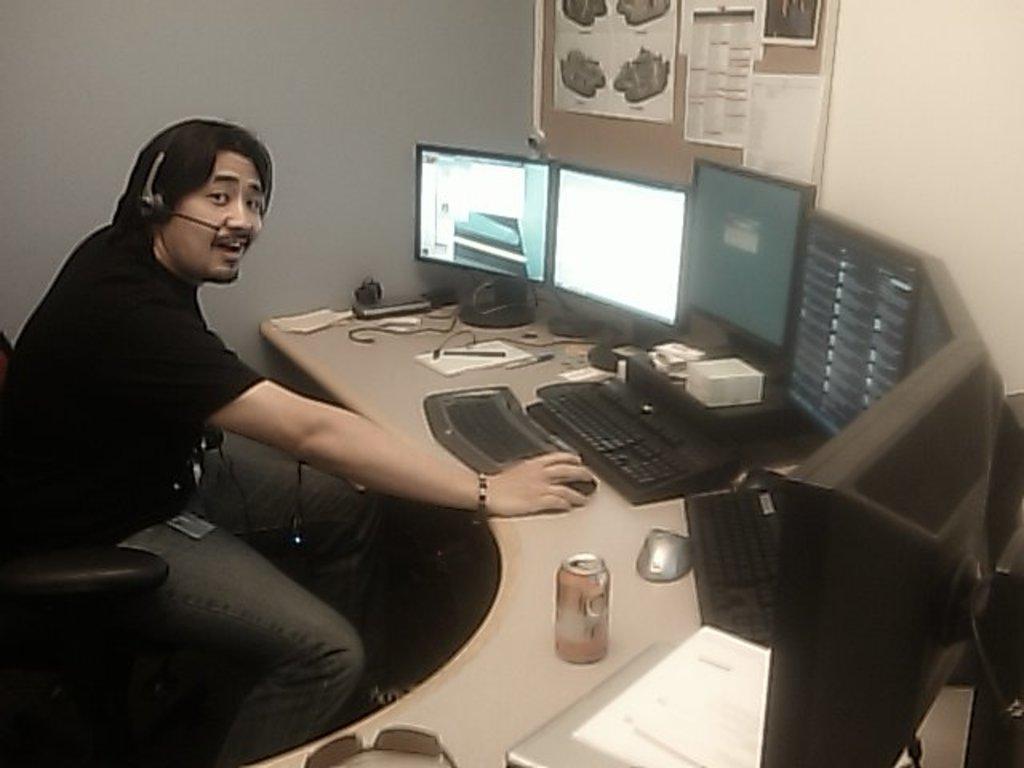Could you give a brief overview of what you see in this image? This is a picture of a man in black t shirt was sitting on a chair and having headset in front of these people there is a table on the table there are tin, keyboards , paper, pen and monitors and the man is also holding a mouse. Behind the man there is a wall and papers. 